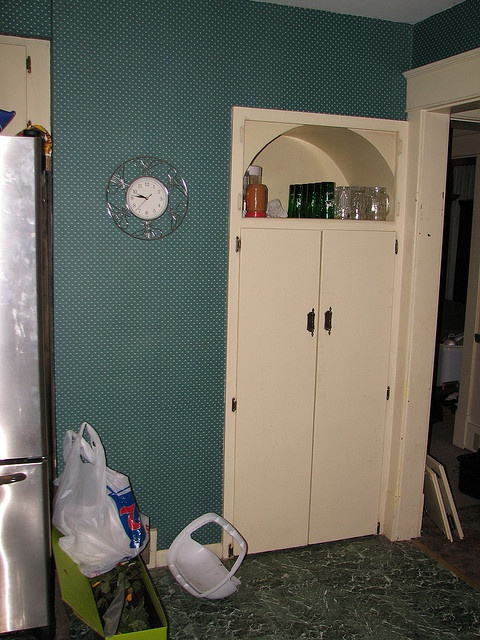Describe the objects in this image and their specific colors. I can see refrigerator in black, darkgray, lightgray, and gray tones, clock in black, darkgray, and lightgray tones, cup in black and gray tones, cup in black, gray, and darkgreen tones, and cup in black and gray tones in this image. 